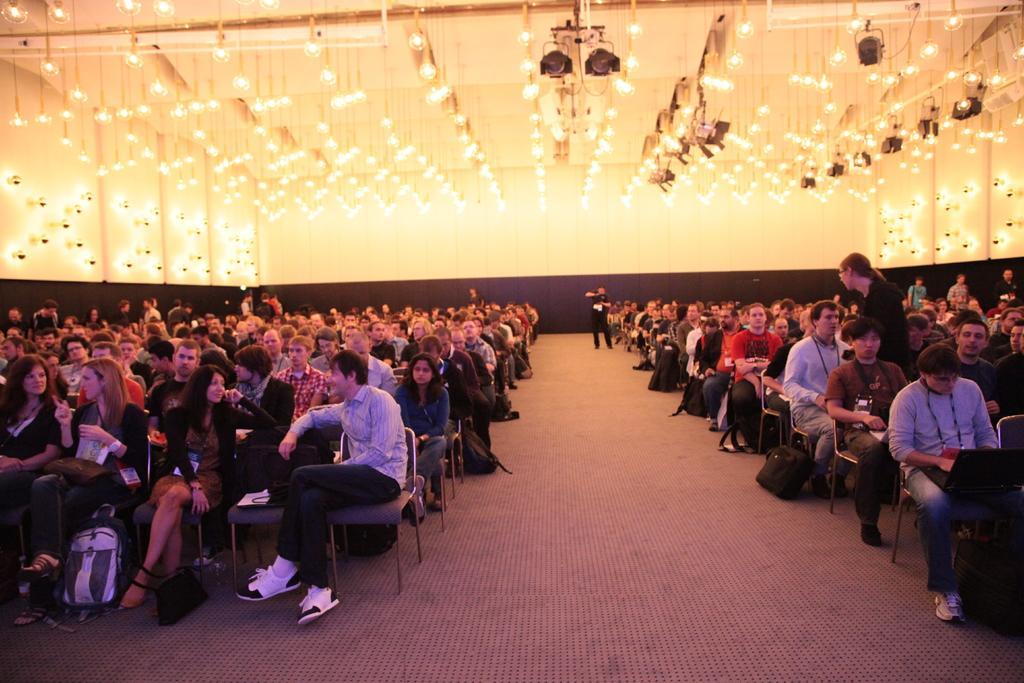Can you describe this image briefly? In this image there is a hall, in that hall there are people sitting on chairs, on the top there are lights. 